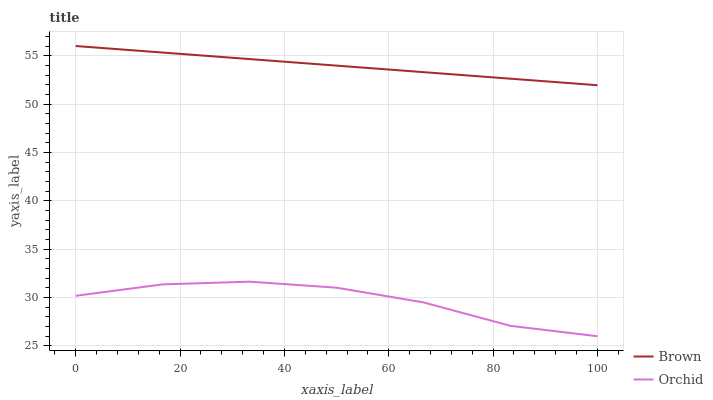Does Orchid have the minimum area under the curve?
Answer yes or no. Yes. Does Brown have the maximum area under the curve?
Answer yes or no. Yes. Does Orchid have the maximum area under the curve?
Answer yes or no. No. Is Brown the smoothest?
Answer yes or no. Yes. Is Orchid the roughest?
Answer yes or no. Yes. Is Orchid the smoothest?
Answer yes or no. No. Does Orchid have the lowest value?
Answer yes or no. Yes. Does Brown have the highest value?
Answer yes or no. Yes. Does Orchid have the highest value?
Answer yes or no. No. Is Orchid less than Brown?
Answer yes or no. Yes. Is Brown greater than Orchid?
Answer yes or no. Yes. Does Orchid intersect Brown?
Answer yes or no. No. 